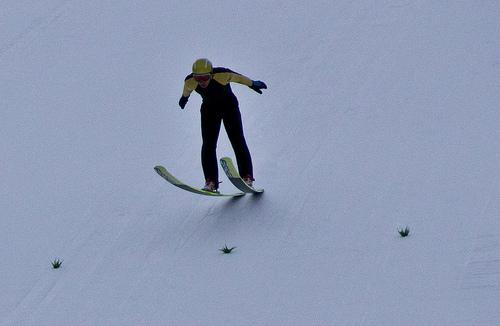Question: where was this picture taken?
Choices:
A. On a ski slope.
B. In a park.
C. On a roller coaster.
D. In a kayak.
Answer with the letter. Answer: A Question: what is the person doing?
Choices:
A. Surfing.
B. Diving.
C. Driving.
D. Skiing.
Answer with the letter. Answer: D Question: what color is the person's gloves?
Choices:
A. Brown.
B. Yellow.
C. Grey.
D. Black.
Answer with the letter. Answer: D 